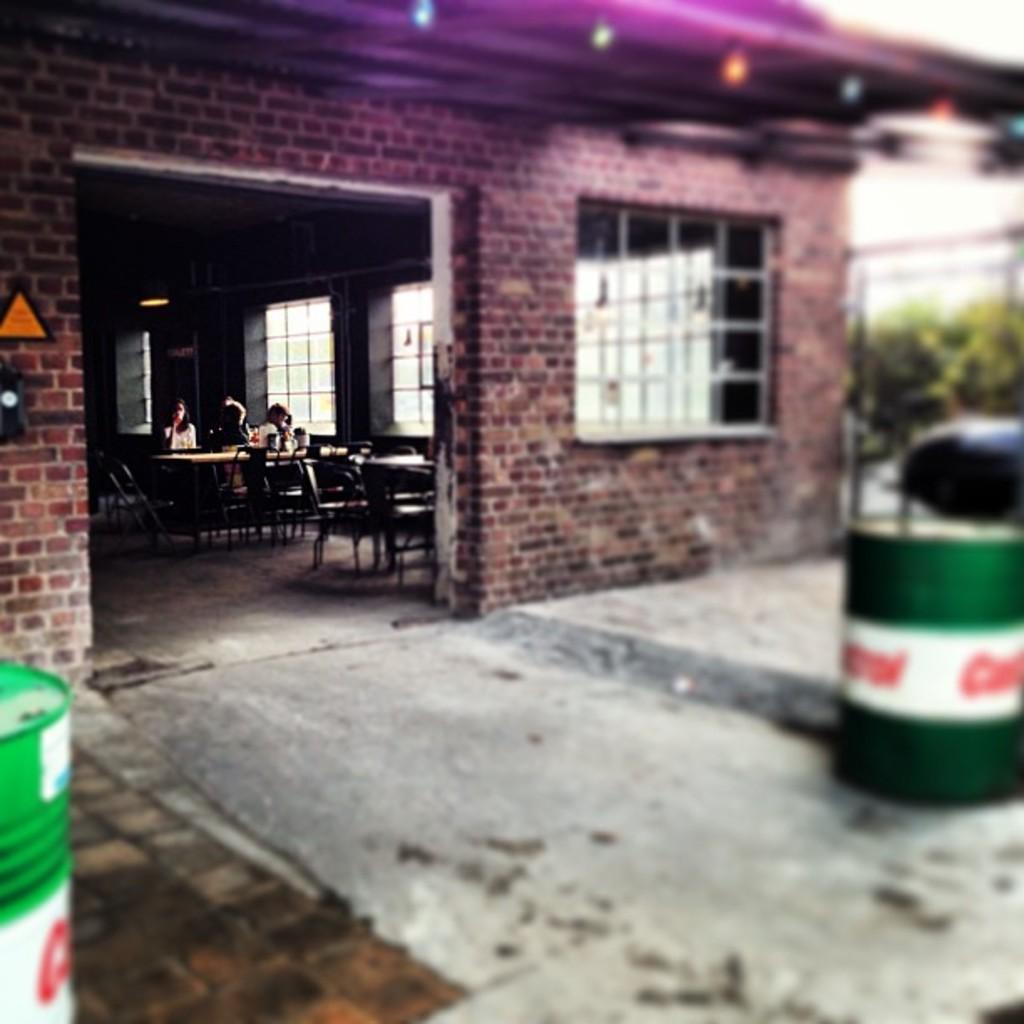In one or two sentences, can you explain what this image depicts? In the image a group of people are sitting on a chair near a table. There is a restaurant in the image. There are two barrels in the image, one is placed at the bottom left most of the image and another is placed at the right most of the image. 